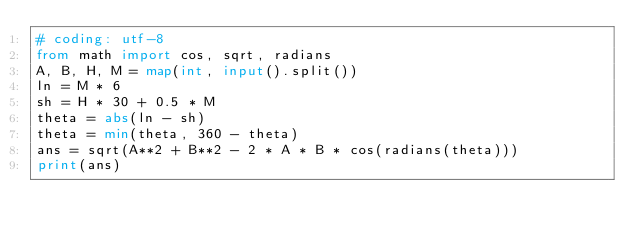<code> <loc_0><loc_0><loc_500><loc_500><_Python_># coding: utf-8
from math import cos, sqrt, radians
A, B, H, M = map(int, input().split())
ln = M * 6
sh = H * 30 + 0.5 * M
theta = abs(ln - sh)
theta = min(theta, 360 - theta)
ans = sqrt(A**2 + B**2 - 2 * A * B * cos(radians(theta)))
print(ans)</code> 